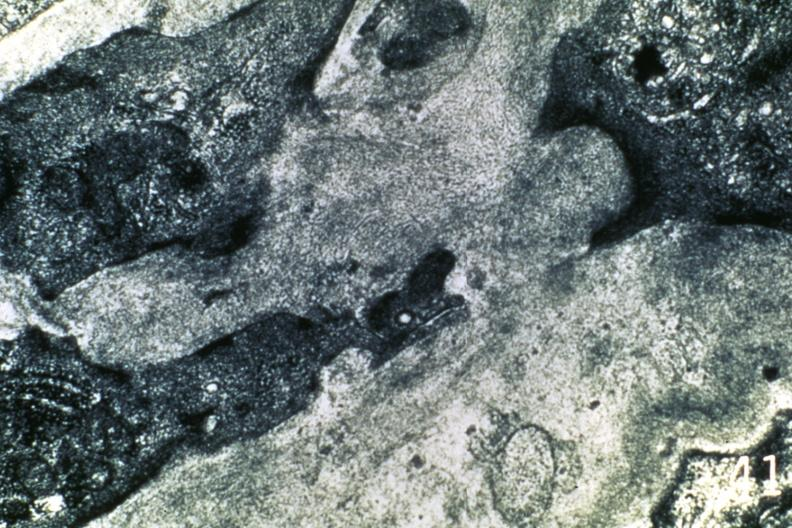s cardiovascular present?
Answer the question using a single word or phrase. Yes 